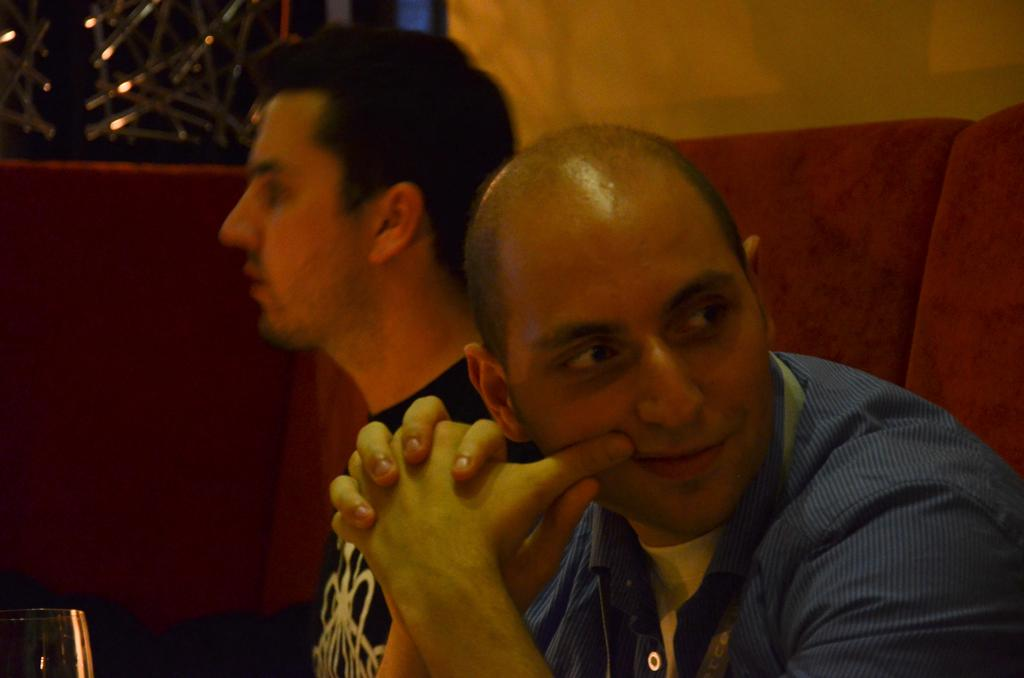How many people are in the image? There are two men in the image. What are the men doing in the image? The men are sitting. What object can be seen in the image besides the men? There is a glass in the image. What is the background of the image? There is a wall in the image. What type of oven can be seen in the image? There is no oven present in the image. How does the kite affect the fog in the image? There is no kite or fog present in the image. 